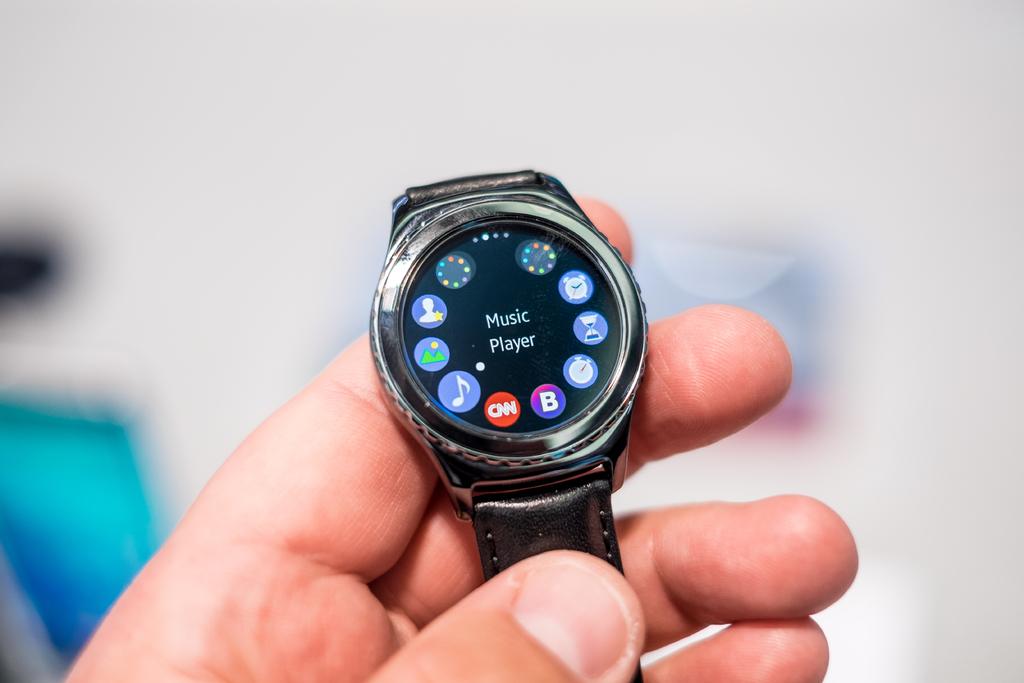What does it say in the middle of the watch?
Provide a short and direct response. Music player. 